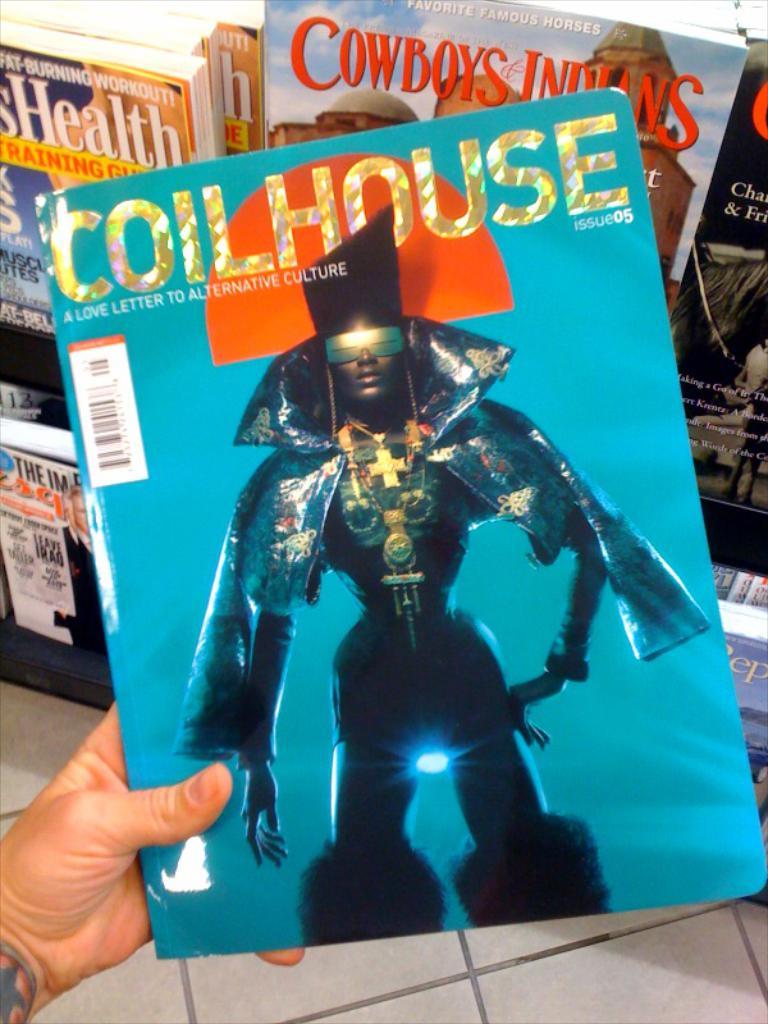What is the name of the magazine that is in a persons hand?
Your response must be concise. Coilhouse. What issue of the magazine is this?
Keep it short and to the point. 05. 